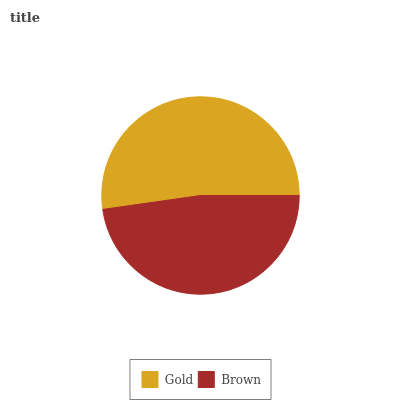Is Brown the minimum?
Answer yes or no. Yes. Is Gold the maximum?
Answer yes or no. Yes. Is Brown the maximum?
Answer yes or no. No. Is Gold greater than Brown?
Answer yes or no. Yes. Is Brown less than Gold?
Answer yes or no. Yes. Is Brown greater than Gold?
Answer yes or no. No. Is Gold less than Brown?
Answer yes or no. No. Is Gold the high median?
Answer yes or no. Yes. Is Brown the low median?
Answer yes or no. Yes. Is Brown the high median?
Answer yes or no. No. Is Gold the low median?
Answer yes or no. No. 